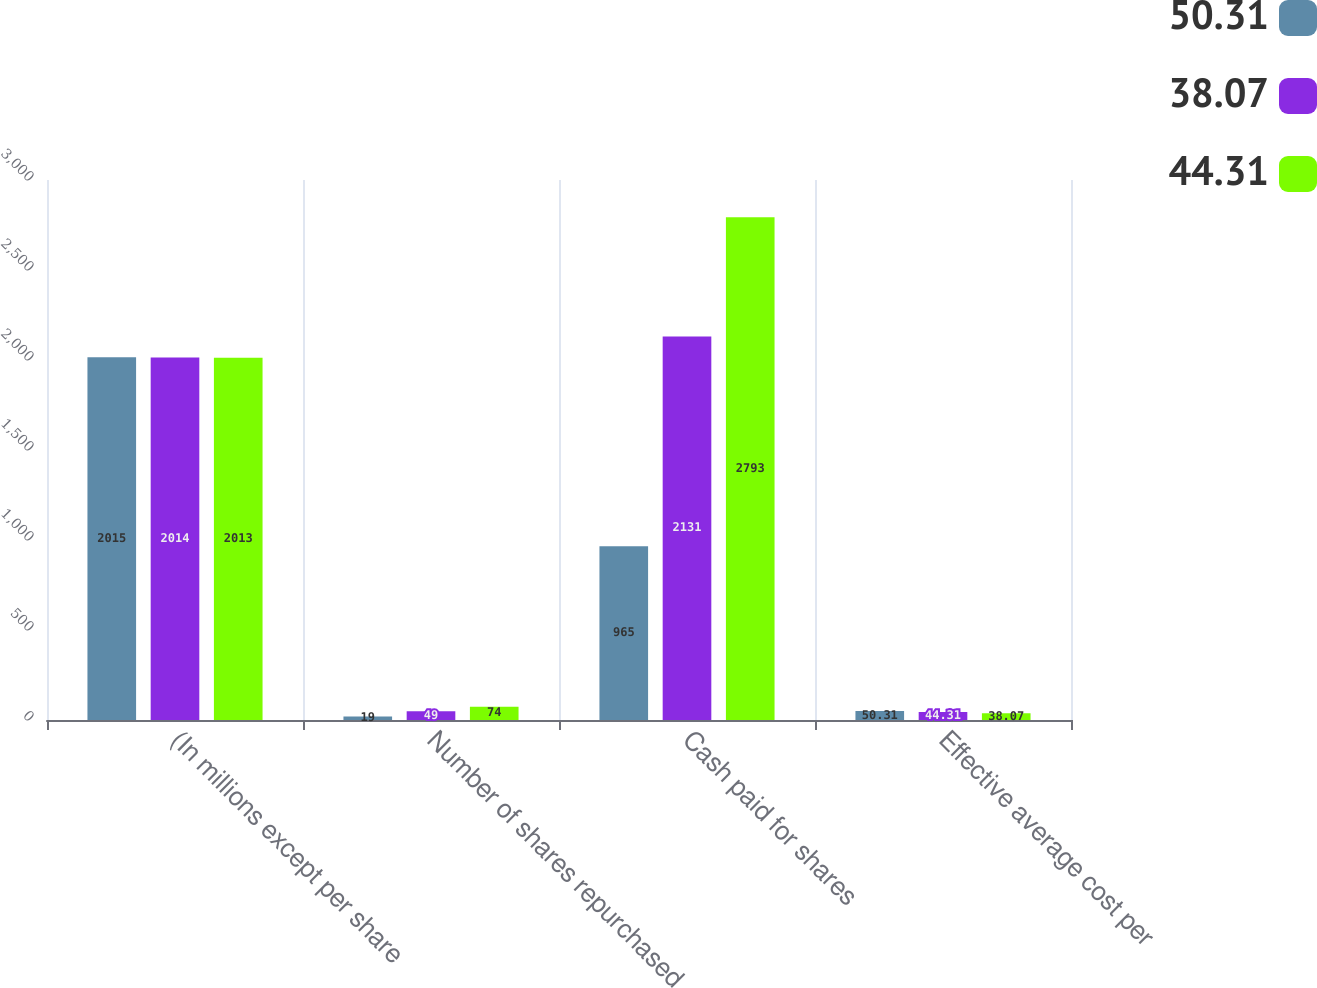Convert chart to OTSL. <chart><loc_0><loc_0><loc_500><loc_500><stacked_bar_chart><ecel><fcel>(In millions except per share<fcel>Number of shares repurchased<fcel>Cash paid for shares<fcel>Effective average cost per<nl><fcel>50.31<fcel>2015<fcel>19<fcel>965<fcel>50.31<nl><fcel>38.07<fcel>2014<fcel>49<fcel>2131<fcel>44.31<nl><fcel>44.31<fcel>2013<fcel>74<fcel>2793<fcel>38.07<nl></chart> 